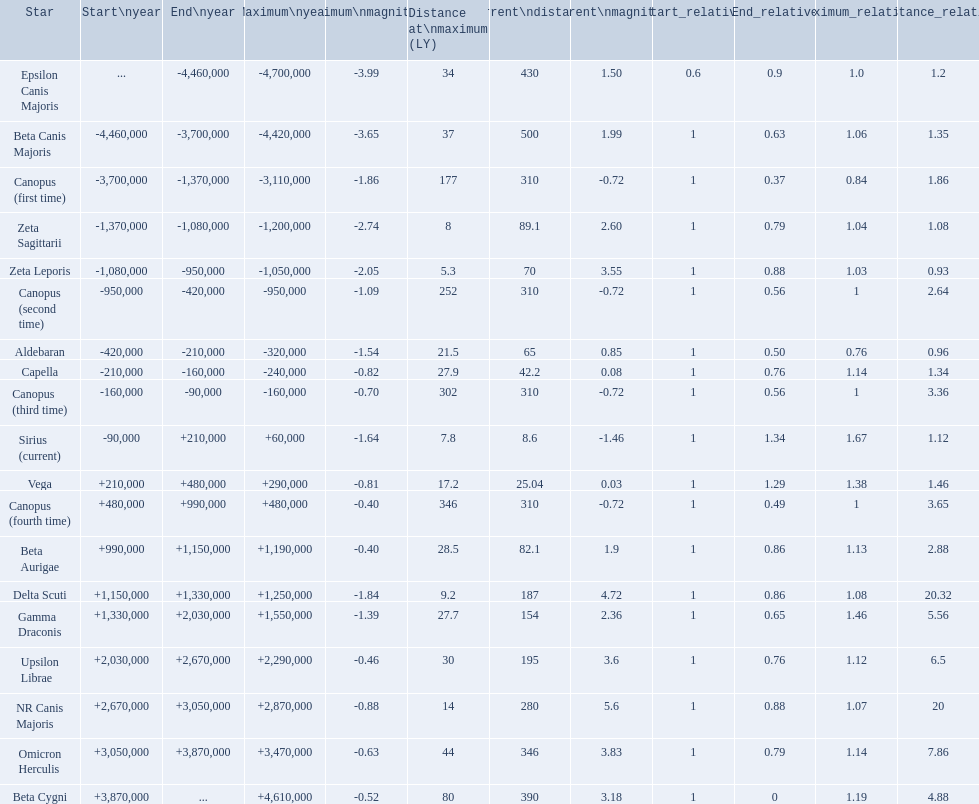What star has a a maximum magnitude of -0.63. Omicron Herculis. What star has a current distance of 390? Beta Cygni. 